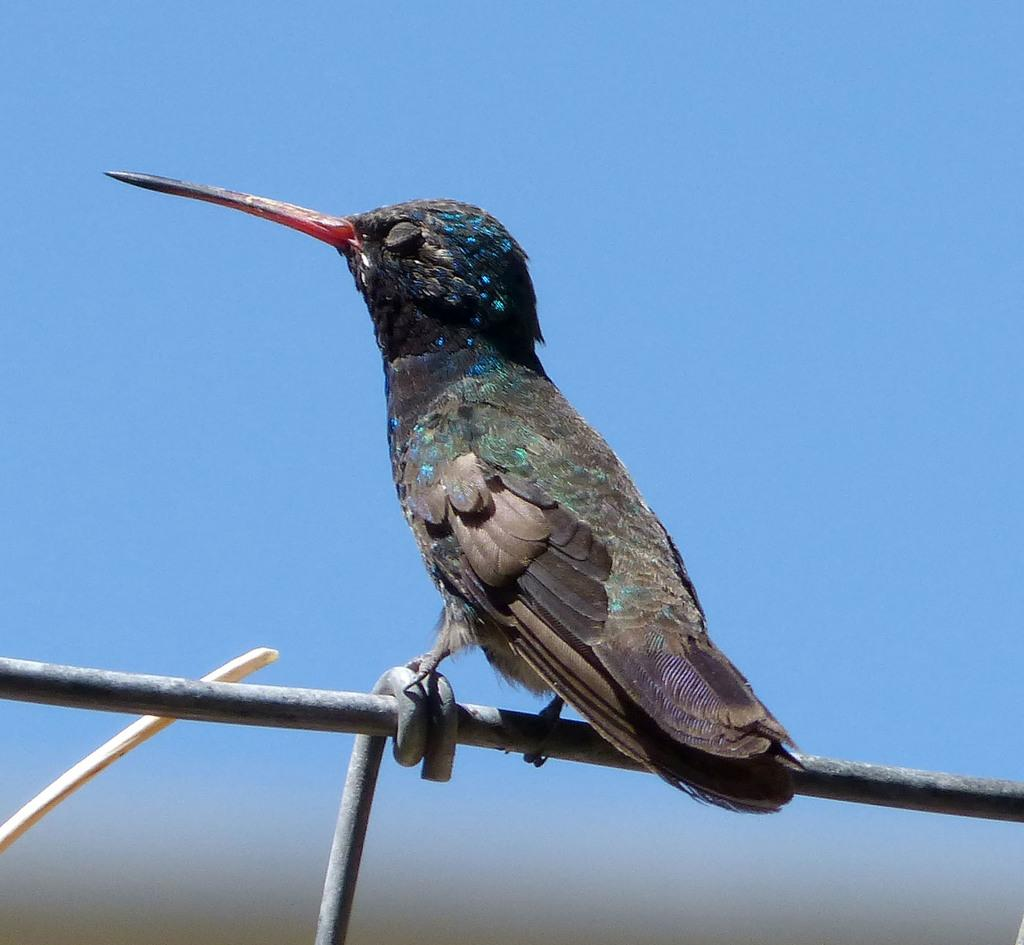What type of animal can be seen in the image? There is a bird in the image. What is the bird standing on? The bird is standing on a rod. Can you describe the color of any object in the image? There is an object in the image that is white in color. What type of insurance does the bird have in the image? There is no mention of insurance in the image, as it features a bird standing on a rod. What scent can be detected from the bird in the image? The image does not provide any information about the scent of the bird. 